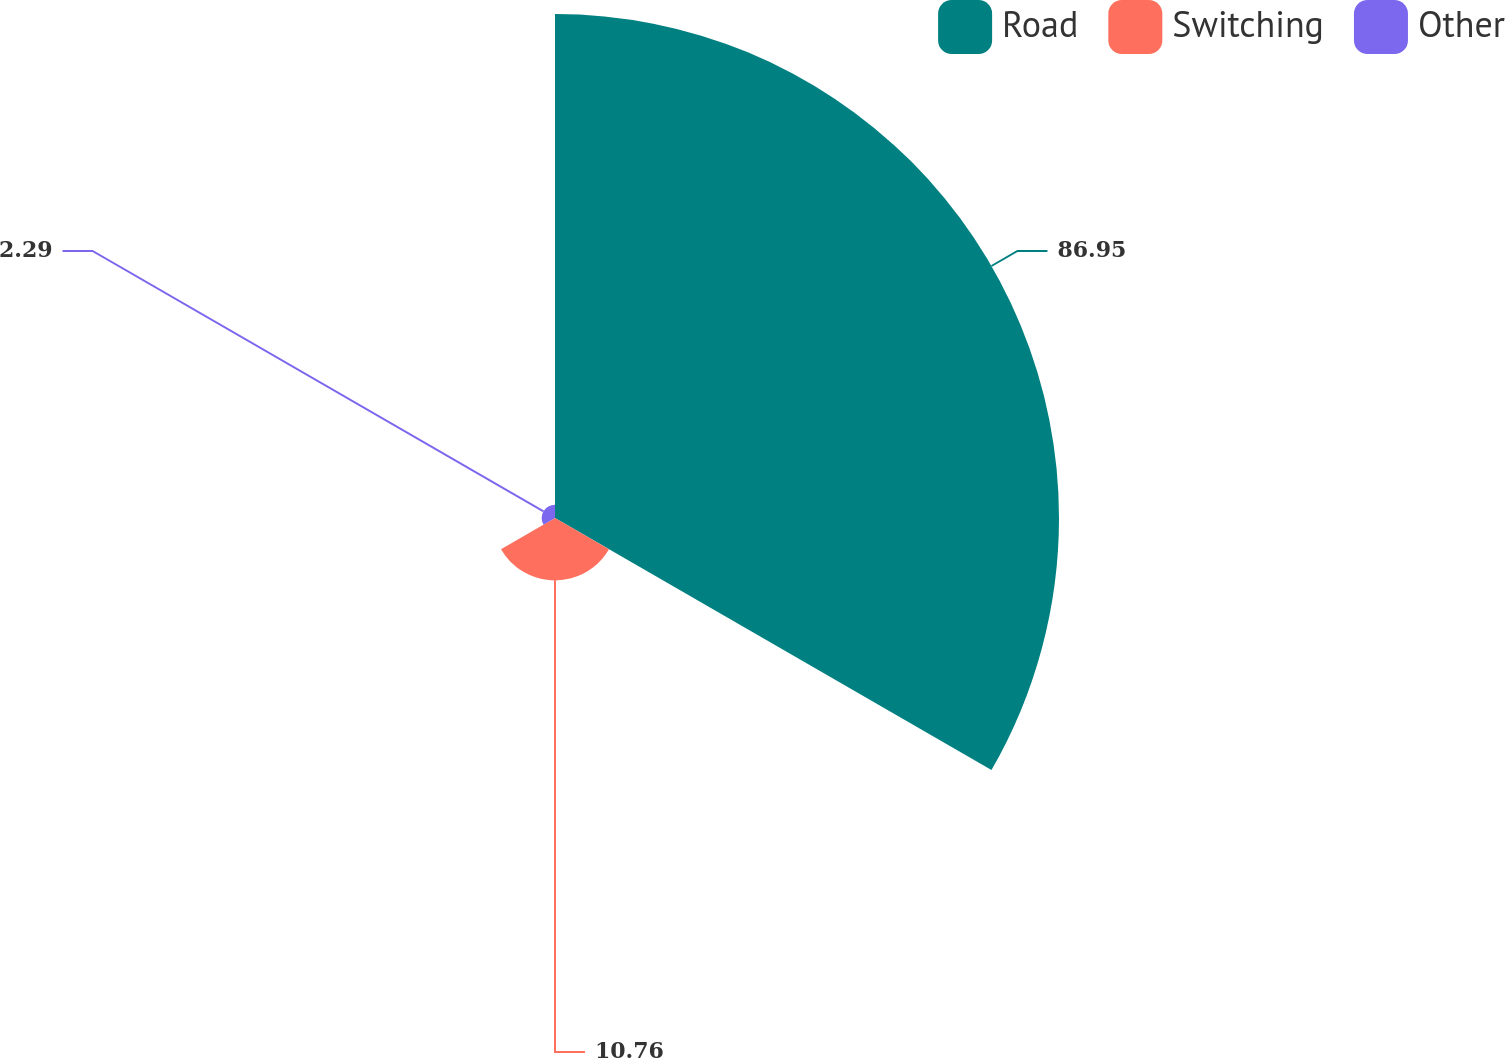Convert chart to OTSL. <chart><loc_0><loc_0><loc_500><loc_500><pie_chart><fcel>Road<fcel>Switching<fcel>Other<nl><fcel>86.95%<fcel>10.76%<fcel>2.29%<nl></chart> 